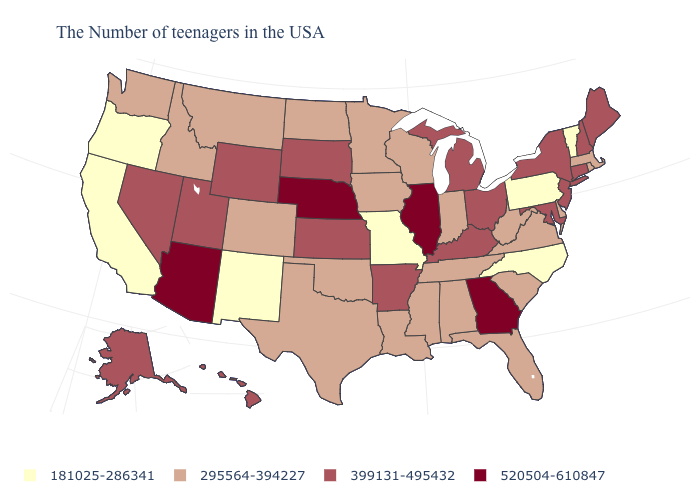Among the states that border Minnesota , does North Dakota have the lowest value?
Be succinct. Yes. Name the states that have a value in the range 181025-286341?
Quick response, please. Vermont, Pennsylvania, North Carolina, Missouri, New Mexico, California, Oregon. Does Vermont have the lowest value in the USA?
Be succinct. Yes. What is the value of New Jersey?
Write a very short answer. 399131-495432. Does Tennessee have the lowest value in the USA?
Short answer required. No. Name the states that have a value in the range 295564-394227?
Answer briefly. Massachusetts, Rhode Island, Delaware, Virginia, South Carolina, West Virginia, Florida, Indiana, Alabama, Tennessee, Wisconsin, Mississippi, Louisiana, Minnesota, Iowa, Oklahoma, Texas, North Dakota, Colorado, Montana, Idaho, Washington. What is the highest value in states that border Illinois?
Short answer required. 399131-495432. Name the states that have a value in the range 399131-495432?
Answer briefly. Maine, New Hampshire, Connecticut, New York, New Jersey, Maryland, Ohio, Michigan, Kentucky, Arkansas, Kansas, South Dakota, Wyoming, Utah, Nevada, Alaska, Hawaii. Does the map have missing data?
Be succinct. No. Among the states that border Tennessee , does Alabama have the lowest value?
Be succinct. No. Name the states that have a value in the range 295564-394227?
Write a very short answer. Massachusetts, Rhode Island, Delaware, Virginia, South Carolina, West Virginia, Florida, Indiana, Alabama, Tennessee, Wisconsin, Mississippi, Louisiana, Minnesota, Iowa, Oklahoma, Texas, North Dakota, Colorado, Montana, Idaho, Washington. Among the states that border Louisiana , does Arkansas have the lowest value?
Short answer required. No. What is the lowest value in the USA?
Be succinct. 181025-286341. Does the map have missing data?
Be succinct. No. What is the value of Louisiana?
Answer briefly. 295564-394227. 